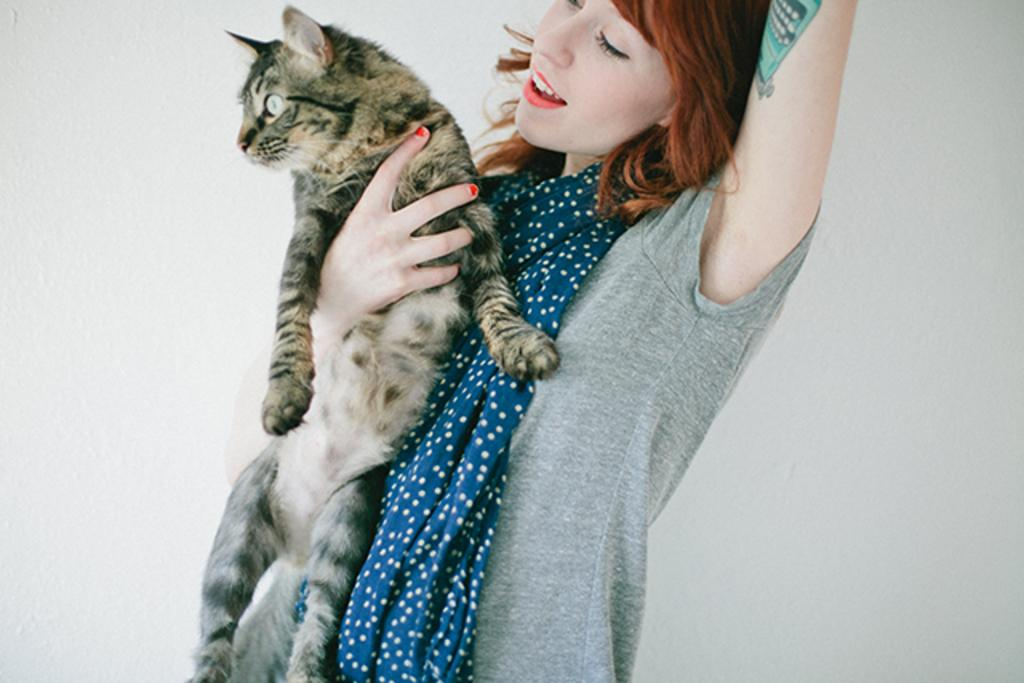Who is present in the image? There is a woman in the image. What is the woman wearing on her upper body? The woman is wearing a t-shirt. What accessory is the woman wearing around her neck? The woman is wearing a scarf. What is the woman holding in her hand? The woman is holding a cat in her hand. What can be seen in the background of the image? There is a wall in the background of the image. What type of chalk is the woman using to draw on the wall in the image? There is no chalk present in the image, and the woman is not drawing on the wall. 